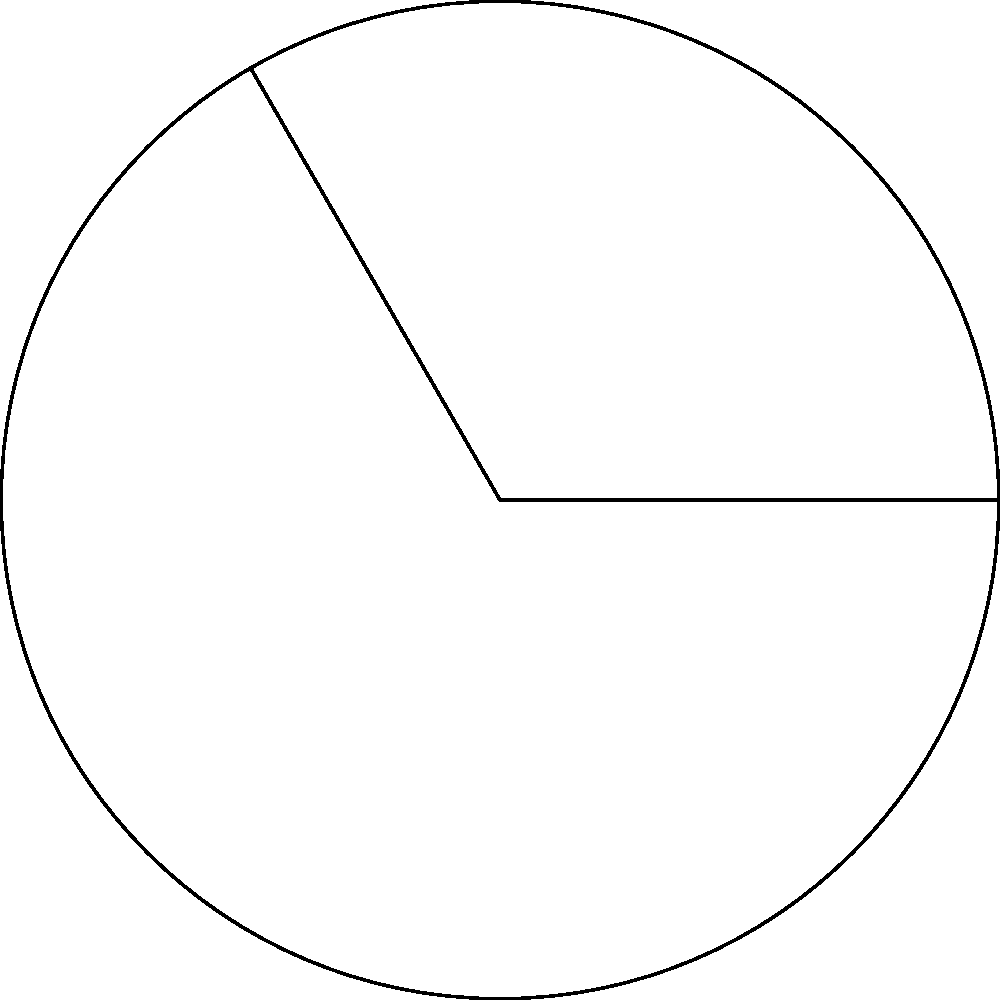As a financial consultant managing investment portfolios, you often deal with circular charts representing asset allocation. Consider a circular sector with a central angle of 120° and a radius of 5 cm. Calculate the area of this sector, representing a specific asset class in the portfolio. Round your answer to two decimal places. To calculate the area of a circular sector, we can follow these steps:

1) The formula for the area of a circular sector is:

   $$A = \frac{1}{2}r^2\theta$$

   Where:
   $A$ is the area of the sector
   $r$ is the radius
   $\theta$ is the central angle in radians

2) We're given the angle in degrees (120°), so we need to convert it to radians:

   $$\theta = 120° \times \frac{\pi}{180°} = \frac{2\pi}{3} \approx 2.0944 \text{ radians}$$

3) Now we can substitute the values into the formula:

   $$A = \frac{1}{2} \times 5^2 \times \frac{2\pi}{3}$$

4) Simplify:

   $$A = \frac{25\pi}{3} \approx 26.18 \text{ cm}^2$$

5) Rounding to two decimal places:

   $$A \approx 26.18 \text{ cm}^2$$
Answer: 26.18 cm² 